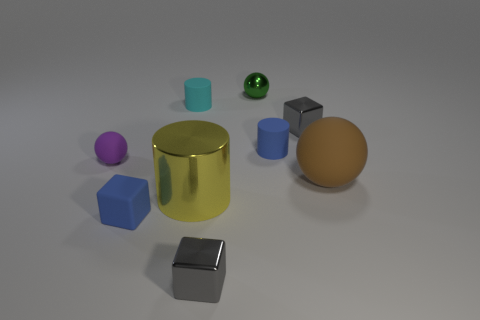Subtract all cubes. How many objects are left? 6 Subtract 0 green cubes. How many objects are left? 9 Subtract all cyan objects. Subtract all cyan objects. How many objects are left? 7 Add 7 large metallic things. How many large metallic things are left? 8 Add 7 big metal things. How many big metal things exist? 8 